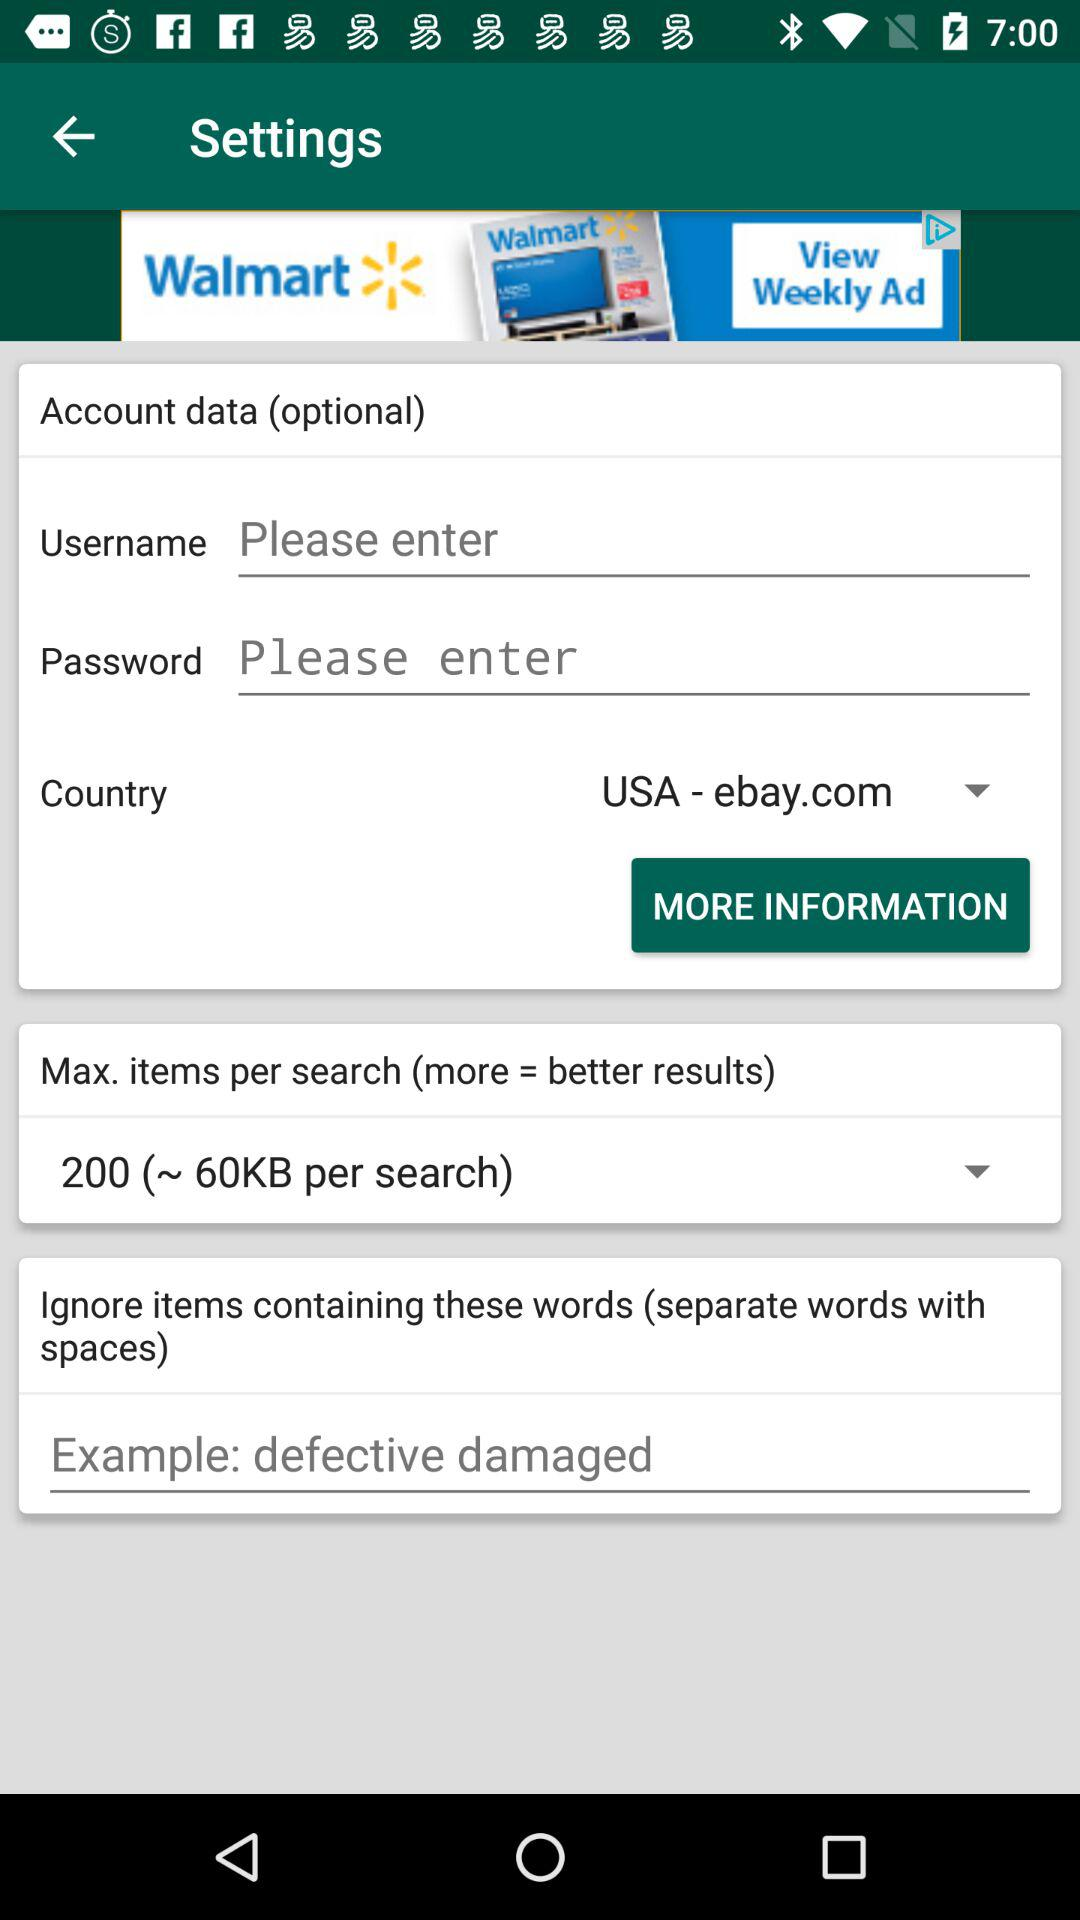How many items can be searched for at once?
Answer the question using a single word or phrase. 200 